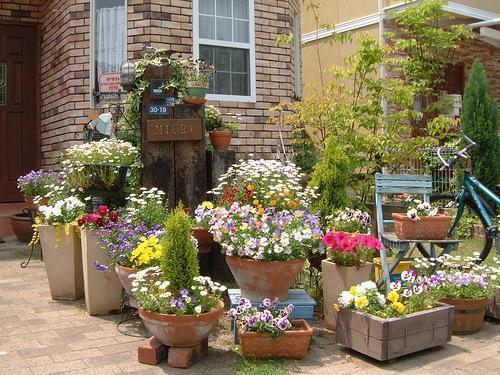How many vases can you see?
Give a very brief answer. 1. How many potted plants are visible?
Give a very brief answer. 10. 